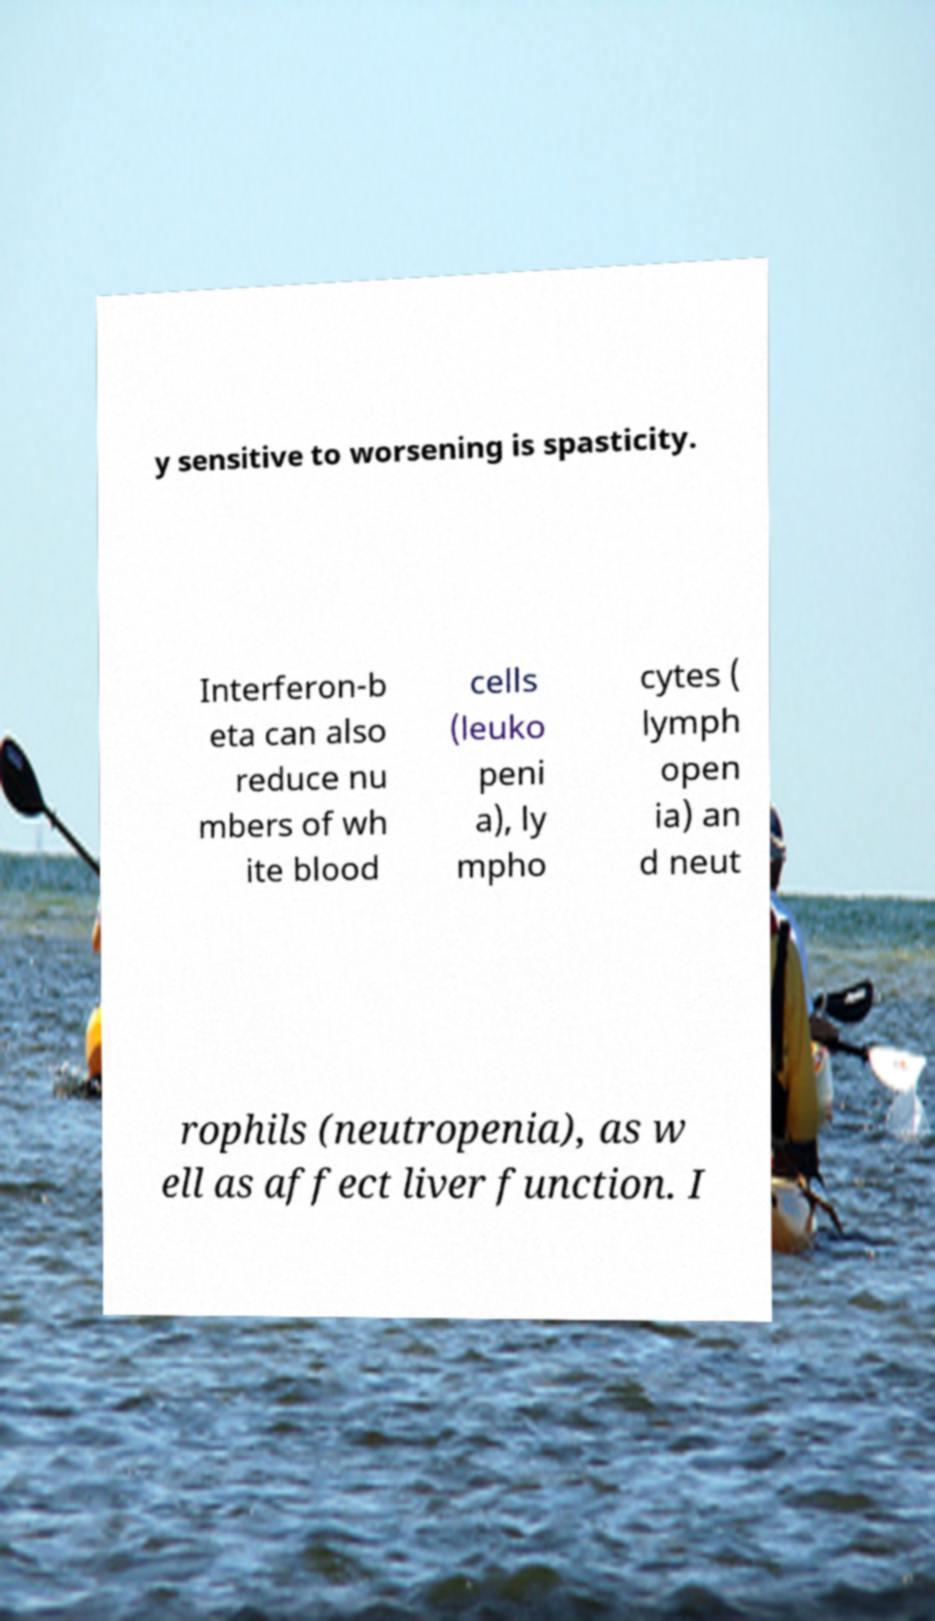Please read and relay the text visible in this image. What does it say? y sensitive to worsening is spasticity. Interferon-b eta can also reduce nu mbers of wh ite blood cells (leuko peni a), ly mpho cytes ( lymph open ia) an d neut rophils (neutropenia), as w ell as affect liver function. I 